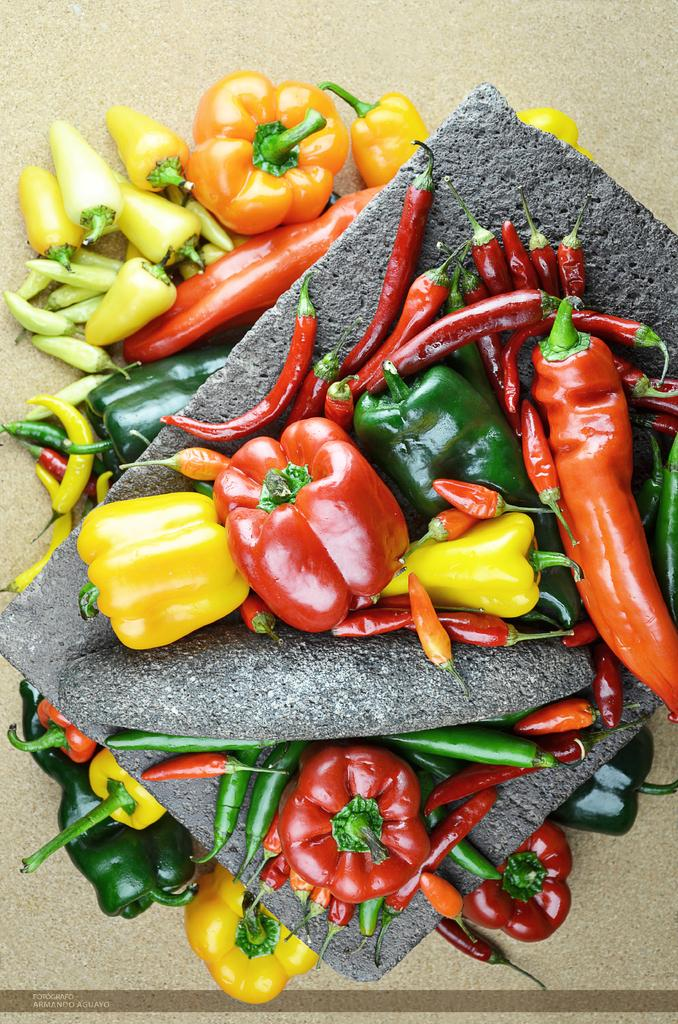What is located in the center of the image? There are stones in the center of the image. What type of food items can be seen in the image? There are red chilies, peppers, and other vegetables in the image. What force is being applied to the vegetables in the image? There is no force being applied to the vegetables in the image; they are simply present. 